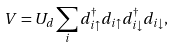<formula> <loc_0><loc_0><loc_500><loc_500>V = U _ { d } \sum _ { i } d ^ { \dag } _ { i \uparrow } d _ { i \uparrow } d ^ { \dag } _ { i \downarrow } d _ { i \downarrow } ,</formula> 